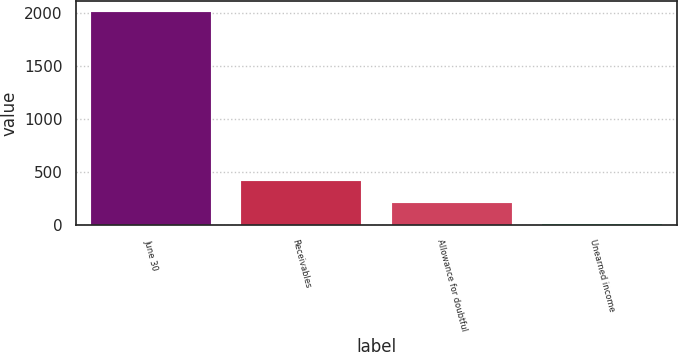Convert chart to OTSL. <chart><loc_0><loc_0><loc_500><loc_500><bar_chart><fcel>June 30<fcel>Receivables<fcel>Allowance for doubtful<fcel>Unearned income<nl><fcel>2009<fcel>412.04<fcel>212.42<fcel>12.8<nl></chart> 